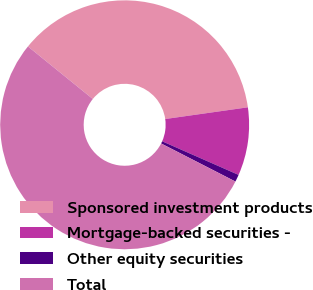<chart> <loc_0><loc_0><loc_500><loc_500><pie_chart><fcel>Sponsored investment products<fcel>Mortgage-backed securities -<fcel>Other equity securities<fcel>Total<nl><fcel>36.92%<fcel>8.84%<fcel>0.94%<fcel>53.3%<nl></chart> 